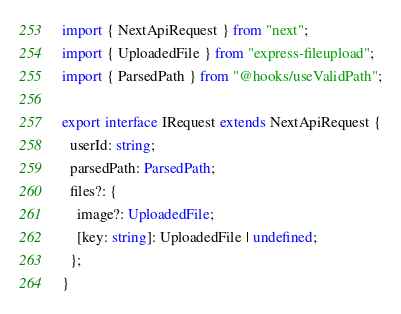Convert code to text. <code><loc_0><loc_0><loc_500><loc_500><_TypeScript_>import { NextApiRequest } from "next";
import { UploadedFile } from "express-fileupload";
import { ParsedPath } from "@hooks/useValidPath";

export interface IRequest extends NextApiRequest {
  userId: string;
  parsedPath: ParsedPath;
  files?: {
    image?: UploadedFile;
    [key: string]: UploadedFile | undefined;
  };
}
</code> 